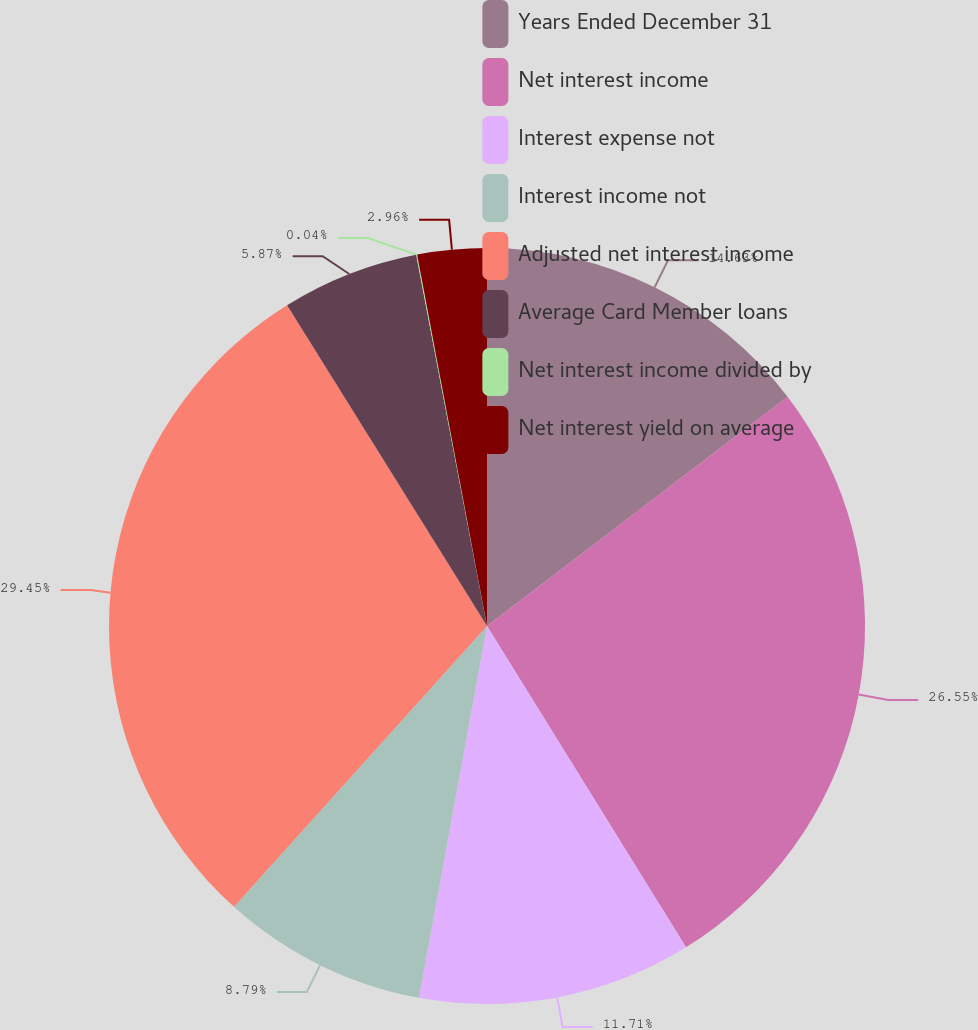Convert chart. <chart><loc_0><loc_0><loc_500><loc_500><pie_chart><fcel>Years Ended December 31<fcel>Net interest income<fcel>Interest expense not<fcel>Interest income not<fcel>Adjusted net interest income<fcel>Average Card Member loans<fcel>Net interest income divided by<fcel>Net interest yield on average<nl><fcel>14.63%<fcel>26.55%<fcel>11.71%<fcel>8.79%<fcel>29.46%<fcel>5.87%<fcel>0.04%<fcel>2.96%<nl></chart> 